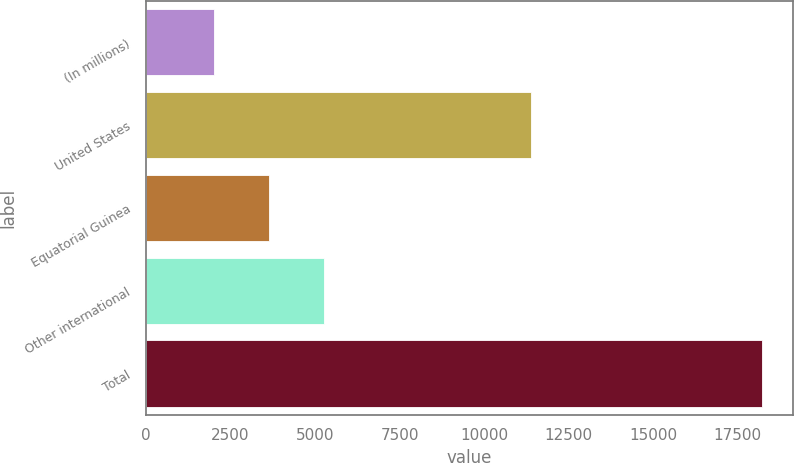Convert chart to OTSL. <chart><loc_0><loc_0><loc_500><loc_500><bar_chart><fcel>(In millions)<fcel>United States<fcel>Equatorial Guinea<fcel>Other international<fcel>Total<nl><fcel>2006<fcel>11401<fcel>3628<fcel>5250<fcel>18226<nl></chart> 